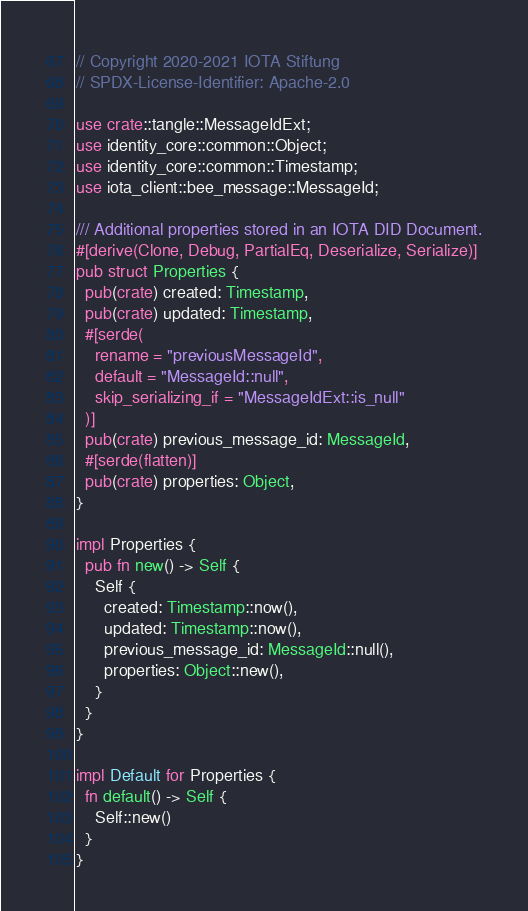Convert code to text. <code><loc_0><loc_0><loc_500><loc_500><_Rust_>// Copyright 2020-2021 IOTA Stiftung
// SPDX-License-Identifier: Apache-2.0

use crate::tangle::MessageIdExt;
use identity_core::common::Object;
use identity_core::common::Timestamp;
use iota_client::bee_message::MessageId;

/// Additional properties stored in an IOTA DID Document.
#[derive(Clone, Debug, PartialEq, Deserialize, Serialize)]
pub struct Properties {
  pub(crate) created: Timestamp,
  pub(crate) updated: Timestamp,
  #[serde(
    rename = "previousMessageId",
    default = "MessageId::null",
    skip_serializing_if = "MessageIdExt::is_null"
  )]
  pub(crate) previous_message_id: MessageId,
  #[serde(flatten)]
  pub(crate) properties: Object,
}

impl Properties {
  pub fn new() -> Self {
    Self {
      created: Timestamp::now(),
      updated: Timestamp::now(),
      previous_message_id: MessageId::null(),
      properties: Object::new(),
    }
  }
}

impl Default for Properties {
  fn default() -> Self {
    Self::new()
  }
}
</code> 